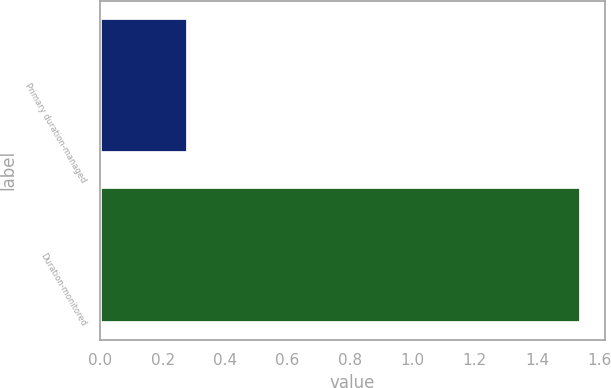Convert chart to OTSL. <chart><loc_0><loc_0><loc_500><loc_500><bar_chart><fcel>Primary duration-managed<fcel>Duration-monitored<nl><fcel>0.28<fcel>1.54<nl></chart> 